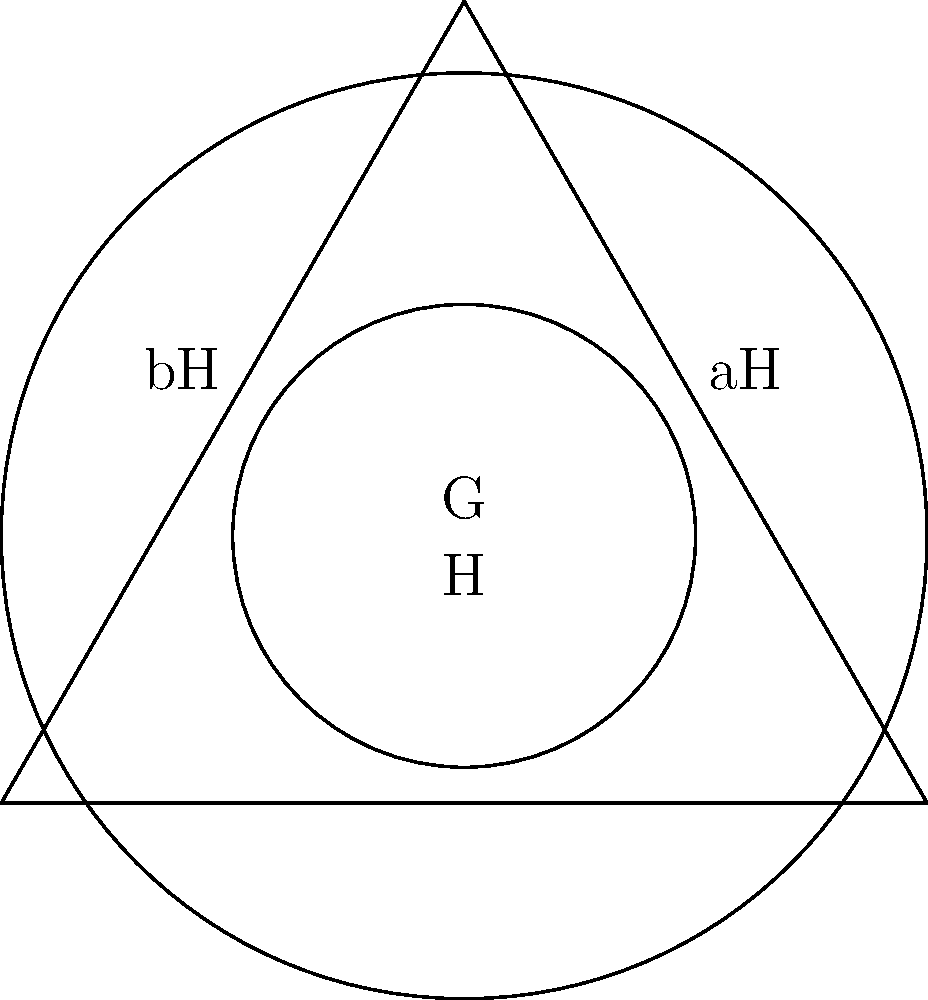In the Venn diagram above, G represents a group, and H is a subgroup of G. The cosets aH and bH are depicted. If |G| = 6 and |H| = 2, determine the index [G:H] and explain its significance in the context of international alliances. To solve this problem and understand its relevance to international alliances, let's follow these steps:

1) Recall that the index [G:H] is defined as the number of distinct cosets of H in G.

2) We can calculate the index using the formula:
   $[G:H] = \frac{|G|}{|H|}$

3) Given:
   $|G| = 6$ (order of group G)
   $|H| = 2$ (order of subgroup H)

4) Substituting these values:
   $[G:H] = \frac{6}{2} = 3$

5) This means there are 3 distinct cosets of H in G, which we can see represented in the Venn diagram:
   - H itself (the inner circle)
   - aH (one of the outer regions)
   - bH (the other outer region)

6) In the context of international alliances:
   - G could represent a larger coalition of countries
   - H could represent a subgroup of countries with closer ties or shared interests
   - The cosets aH and bH could represent different factions or blocs within the larger coalition

7) The index [G:H] = 3 suggests that the coalition can be divided into three distinct groups, each potentially representing a different stance or set of priorities in negotiations.

8) Understanding this structure can be crucial for a skillful negotiator, as it provides insight into the potential dynamics and divisions within the larger group, allowing for more effective alliance formation and advocacy strategies.
Answer: [G:H] = 3 